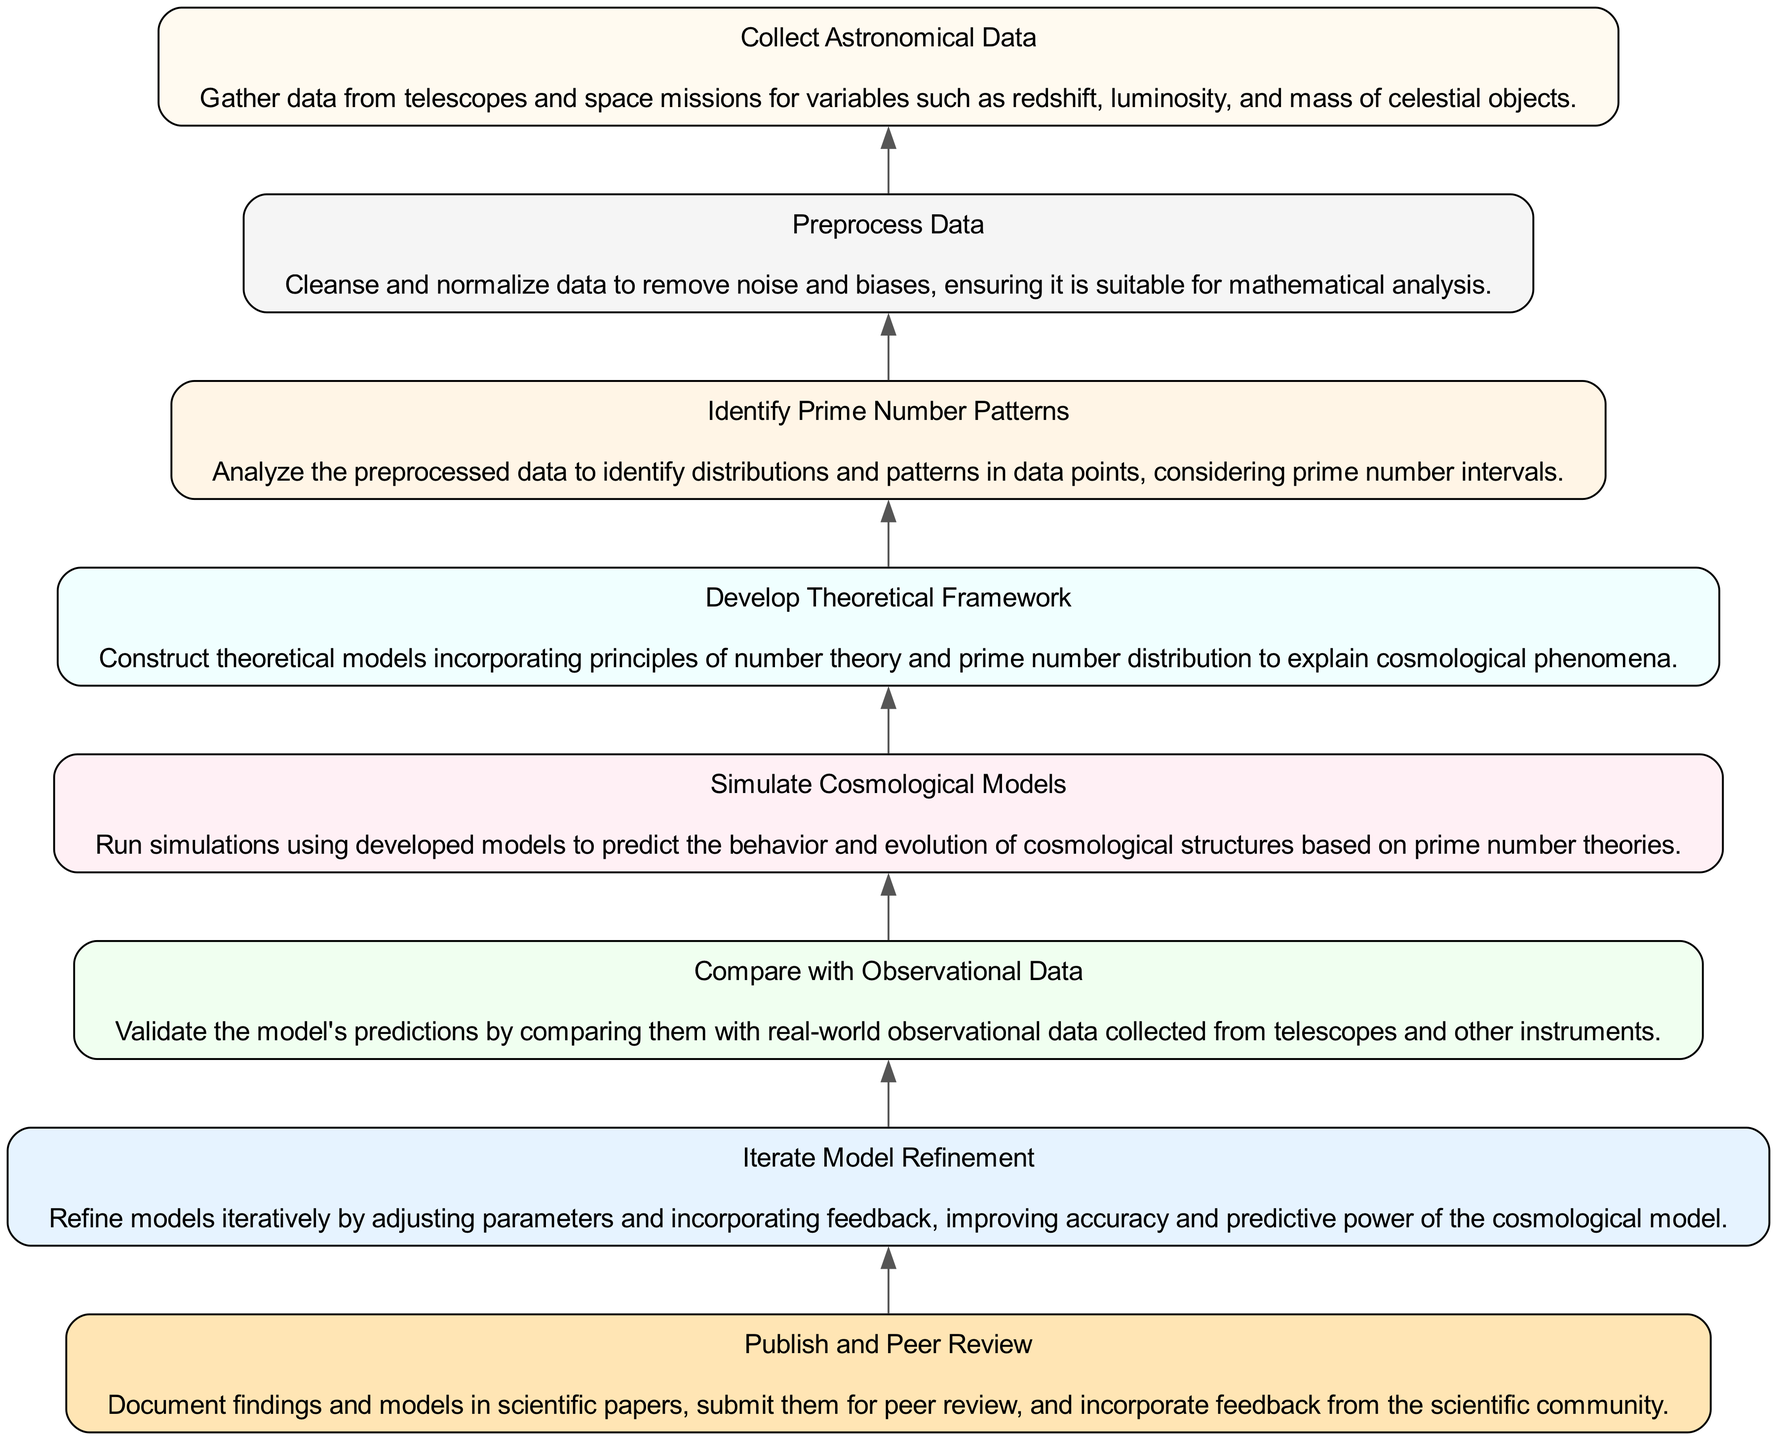What is the first step in the flow chart? The first step in the flow chart, which appears at the bottom, is "Collect Astronomical Data." This is the initial action before any other steps are performed in the process.
Answer: Collect Astronomical Data How many steps are there in total? By counting the number of individual nodes in the diagram, we find there are eight distinct steps listed, each representing a part of the validation process.
Answer: Eight What is the last step in the sequence? The last step at the top of the flow chart is "Publish and Peer Review," indicating the final action taken after all previous steps have been completed.
Answer: Publish and Peer Review What step directly follows "Simulate Cosmological Models"? "Compare with Observational Data" is the step that comes directly after "Simulate Cosmological Models," reflecting the logical progression of validating simulation results.
Answer: Compare with Observational Data Which step involves adjusting parameters to improve accuracy? "Iterate Model Refinement" specifically focuses on refining models by making adjustments based on feedback to enhance their precision and reliability.
Answer: Iterate Model Refinement What is the connection between "Identify Prime Number Patterns" and "Develop Theoretical Framework"? "Identify Prime Number Patterns" leads to "Develop Theoretical Framework," indicating that recognizing patterns in data is fundamental for creating a theoretical model in this process.
Answer: Develop Theoretical Framework What action is taken before publishing findings? The action occurring before publishing findings is "Iterate Model Refinement," which ensures that the models are as accurate and robust as possible prior to documentation and peer evaluation.
Answer: Iterate Model Refinement Which two steps are closely related in the validation process? "Simulate Cosmological Models" and "Compare with Observational Data" are closely related because the simulation's predictions must be validated against actual observations.
Answer: Simulate Cosmological Models and Compare with Observational Data 